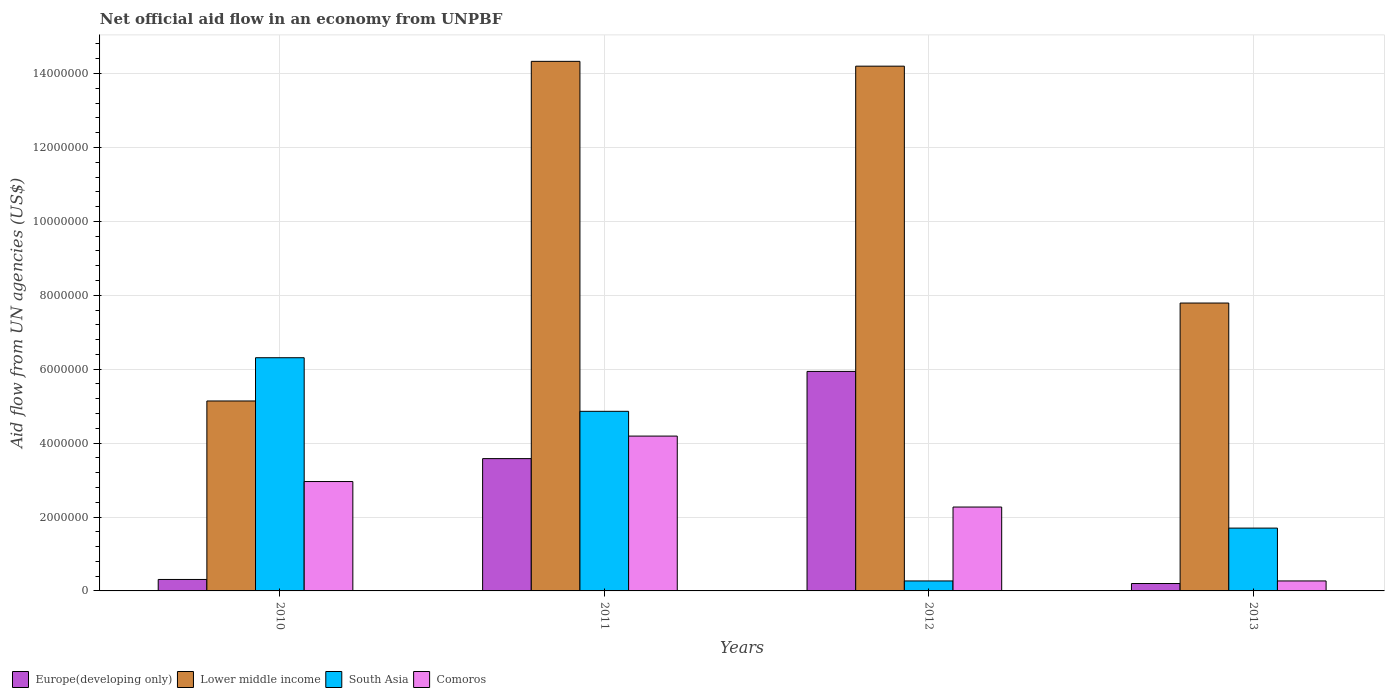How many groups of bars are there?
Offer a terse response. 4. Are the number of bars per tick equal to the number of legend labels?
Your response must be concise. Yes. How many bars are there on the 1st tick from the left?
Provide a short and direct response. 4. What is the label of the 1st group of bars from the left?
Provide a succinct answer. 2010. What is the net official aid flow in Comoros in 2013?
Your answer should be compact. 2.70e+05. Across all years, what is the maximum net official aid flow in South Asia?
Your response must be concise. 6.31e+06. Across all years, what is the minimum net official aid flow in Europe(developing only)?
Make the answer very short. 2.00e+05. What is the total net official aid flow in Europe(developing only) in the graph?
Offer a very short reply. 1.00e+07. What is the difference between the net official aid flow in South Asia in 2011 and that in 2012?
Your response must be concise. 4.59e+06. What is the difference between the net official aid flow in South Asia in 2010 and the net official aid flow in Europe(developing only) in 2012?
Your response must be concise. 3.70e+05. What is the average net official aid flow in Lower middle income per year?
Your response must be concise. 1.04e+07. In the year 2013, what is the difference between the net official aid flow in South Asia and net official aid flow in Comoros?
Offer a terse response. 1.43e+06. What is the ratio of the net official aid flow in Lower middle income in 2011 to that in 2012?
Ensure brevity in your answer.  1.01. What is the difference between the highest and the second highest net official aid flow in South Asia?
Offer a terse response. 1.45e+06. What is the difference between the highest and the lowest net official aid flow in Europe(developing only)?
Your response must be concise. 5.74e+06. Is it the case that in every year, the sum of the net official aid flow in Comoros and net official aid flow in South Asia is greater than the sum of net official aid flow in Europe(developing only) and net official aid flow in Lower middle income?
Your response must be concise. No. What does the 3rd bar from the left in 2013 represents?
Give a very brief answer. South Asia. What does the 1st bar from the right in 2012 represents?
Provide a succinct answer. Comoros. How many years are there in the graph?
Your answer should be compact. 4. What is the difference between two consecutive major ticks on the Y-axis?
Provide a succinct answer. 2.00e+06. Are the values on the major ticks of Y-axis written in scientific E-notation?
Your answer should be compact. No. Does the graph contain any zero values?
Your response must be concise. No. Does the graph contain grids?
Offer a very short reply. Yes. Where does the legend appear in the graph?
Your answer should be very brief. Bottom left. How many legend labels are there?
Offer a terse response. 4. How are the legend labels stacked?
Provide a succinct answer. Horizontal. What is the title of the graph?
Your answer should be very brief. Net official aid flow in an economy from UNPBF. Does "El Salvador" appear as one of the legend labels in the graph?
Give a very brief answer. No. What is the label or title of the X-axis?
Keep it short and to the point. Years. What is the label or title of the Y-axis?
Offer a terse response. Aid flow from UN agencies (US$). What is the Aid flow from UN agencies (US$) in Europe(developing only) in 2010?
Offer a terse response. 3.10e+05. What is the Aid flow from UN agencies (US$) in Lower middle income in 2010?
Ensure brevity in your answer.  5.14e+06. What is the Aid flow from UN agencies (US$) in South Asia in 2010?
Your answer should be very brief. 6.31e+06. What is the Aid flow from UN agencies (US$) of Comoros in 2010?
Ensure brevity in your answer.  2.96e+06. What is the Aid flow from UN agencies (US$) of Europe(developing only) in 2011?
Your answer should be compact. 3.58e+06. What is the Aid flow from UN agencies (US$) of Lower middle income in 2011?
Your response must be concise. 1.43e+07. What is the Aid flow from UN agencies (US$) in South Asia in 2011?
Your answer should be compact. 4.86e+06. What is the Aid flow from UN agencies (US$) in Comoros in 2011?
Provide a short and direct response. 4.19e+06. What is the Aid flow from UN agencies (US$) of Europe(developing only) in 2012?
Provide a succinct answer. 5.94e+06. What is the Aid flow from UN agencies (US$) of Lower middle income in 2012?
Ensure brevity in your answer.  1.42e+07. What is the Aid flow from UN agencies (US$) of Comoros in 2012?
Your answer should be compact. 2.27e+06. What is the Aid flow from UN agencies (US$) of Europe(developing only) in 2013?
Provide a short and direct response. 2.00e+05. What is the Aid flow from UN agencies (US$) of Lower middle income in 2013?
Provide a short and direct response. 7.79e+06. What is the Aid flow from UN agencies (US$) in South Asia in 2013?
Your answer should be very brief. 1.70e+06. Across all years, what is the maximum Aid flow from UN agencies (US$) of Europe(developing only)?
Provide a short and direct response. 5.94e+06. Across all years, what is the maximum Aid flow from UN agencies (US$) of Lower middle income?
Provide a succinct answer. 1.43e+07. Across all years, what is the maximum Aid flow from UN agencies (US$) in South Asia?
Keep it short and to the point. 6.31e+06. Across all years, what is the maximum Aid flow from UN agencies (US$) of Comoros?
Make the answer very short. 4.19e+06. Across all years, what is the minimum Aid flow from UN agencies (US$) of Europe(developing only)?
Provide a short and direct response. 2.00e+05. Across all years, what is the minimum Aid flow from UN agencies (US$) in Lower middle income?
Provide a succinct answer. 5.14e+06. Across all years, what is the minimum Aid flow from UN agencies (US$) in South Asia?
Your response must be concise. 2.70e+05. What is the total Aid flow from UN agencies (US$) of Europe(developing only) in the graph?
Your response must be concise. 1.00e+07. What is the total Aid flow from UN agencies (US$) of Lower middle income in the graph?
Give a very brief answer. 4.15e+07. What is the total Aid flow from UN agencies (US$) of South Asia in the graph?
Your response must be concise. 1.31e+07. What is the total Aid flow from UN agencies (US$) in Comoros in the graph?
Keep it short and to the point. 9.69e+06. What is the difference between the Aid flow from UN agencies (US$) in Europe(developing only) in 2010 and that in 2011?
Provide a short and direct response. -3.27e+06. What is the difference between the Aid flow from UN agencies (US$) in Lower middle income in 2010 and that in 2011?
Offer a terse response. -9.19e+06. What is the difference between the Aid flow from UN agencies (US$) of South Asia in 2010 and that in 2011?
Offer a very short reply. 1.45e+06. What is the difference between the Aid flow from UN agencies (US$) in Comoros in 2010 and that in 2011?
Provide a short and direct response. -1.23e+06. What is the difference between the Aid flow from UN agencies (US$) of Europe(developing only) in 2010 and that in 2012?
Offer a terse response. -5.63e+06. What is the difference between the Aid flow from UN agencies (US$) in Lower middle income in 2010 and that in 2012?
Your answer should be compact. -9.06e+06. What is the difference between the Aid flow from UN agencies (US$) in South Asia in 2010 and that in 2012?
Make the answer very short. 6.04e+06. What is the difference between the Aid flow from UN agencies (US$) of Comoros in 2010 and that in 2012?
Ensure brevity in your answer.  6.90e+05. What is the difference between the Aid flow from UN agencies (US$) in Lower middle income in 2010 and that in 2013?
Your answer should be very brief. -2.65e+06. What is the difference between the Aid flow from UN agencies (US$) in South Asia in 2010 and that in 2013?
Your answer should be compact. 4.61e+06. What is the difference between the Aid flow from UN agencies (US$) in Comoros in 2010 and that in 2013?
Offer a very short reply. 2.69e+06. What is the difference between the Aid flow from UN agencies (US$) of Europe(developing only) in 2011 and that in 2012?
Your response must be concise. -2.36e+06. What is the difference between the Aid flow from UN agencies (US$) of South Asia in 2011 and that in 2012?
Offer a terse response. 4.59e+06. What is the difference between the Aid flow from UN agencies (US$) of Comoros in 2011 and that in 2012?
Your response must be concise. 1.92e+06. What is the difference between the Aid flow from UN agencies (US$) of Europe(developing only) in 2011 and that in 2013?
Provide a succinct answer. 3.38e+06. What is the difference between the Aid flow from UN agencies (US$) of Lower middle income in 2011 and that in 2013?
Offer a very short reply. 6.54e+06. What is the difference between the Aid flow from UN agencies (US$) in South Asia in 2011 and that in 2013?
Offer a terse response. 3.16e+06. What is the difference between the Aid flow from UN agencies (US$) of Comoros in 2011 and that in 2013?
Your answer should be compact. 3.92e+06. What is the difference between the Aid flow from UN agencies (US$) in Europe(developing only) in 2012 and that in 2013?
Your answer should be compact. 5.74e+06. What is the difference between the Aid flow from UN agencies (US$) in Lower middle income in 2012 and that in 2013?
Keep it short and to the point. 6.41e+06. What is the difference between the Aid flow from UN agencies (US$) in South Asia in 2012 and that in 2013?
Provide a succinct answer. -1.43e+06. What is the difference between the Aid flow from UN agencies (US$) in Europe(developing only) in 2010 and the Aid flow from UN agencies (US$) in Lower middle income in 2011?
Offer a very short reply. -1.40e+07. What is the difference between the Aid flow from UN agencies (US$) of Europe(developing only) in 2010 and the Aid flow from UN agencies (US$) of South Asia in 2011?
Give a very brief answer. -4.55e+06. What is the difference between the Aid flow from UN agencies (US$) in Europe(developing only) in 2010 and the Aid flow from UN agencies (US$) in Comoros in 2011?
Ensure brevity in your answer.  -3.88e+06. What is the difference between the Aid flow from UN agencies (US$) of Lower middle income in 2010 and the Aid flow from UN agencies (US$) of Comoros in 2011?
Make the answer very short. 9.50e+05. What is the difference between the Aid flow from UN agencies (US$) of South Asia in 2010 and the Aid flow from UN agencies (US$) of Comoros in 2011?
Offer a very short reply. 2.12e+06. What is the difference between the Aid flow from UN agencies (US$) of Europe(developing only) in 2010 and the Aid flow from UN agencies (US$) of Lower middle income in 2012?
Offer a terse response. -1.39e+07. What is the difference between the Aid flow from UN agencies (US$) of Europe(developing only) in 2010 and the Aid flow from UN agencies (US$) of South Asia in 2012?
Offer a very short reply. 4.00e+04. What is the difference between the Aid flow from UN agencies (US$) of Europe(developing only) in 2010 and the Aid flow from UN agencies (US$) of Comoros in 2012?
Your response must be concise. -1.96e+06. What is the difference between the Aid flow from UN agencies (US$) in Lower middle income in 2010 and the Aid flow from UN agencies (US$) in South Asia in 2012?
Your response must be concise. 4.87e+06. What is the difference between the Aid flow from UN agencies (US$) of Lower middle income in 2010 and the Aid flow from UN agencies (US$) of Comoros in 2012?
Provide a short and direct response. 2.87e+06. What is the difference between the Aid flow from UN agencies (US$) of South Asia in 2010 and the Aid flow from UN agencies (US$) of Comoros in 2012?
Give a very brief answer. 4.04e+06. What is the difference between the Aid flow from UN agencies (US$) of Europe(developing only) in 2010 and the Aid flow from UN agencies (US$) of Lower middle income in 2013?
Give a very brief answer. -7.48e+06. What is the difference between the Aid flow from UN agencies (US$) in Europe(developing only) in 2010 and the Aid flow from UN agencies (US$) in South Asia in 2013?
Offer a terse response. -1.39e+06. What is the difference between the Aid flow from UN agencies (US$) of Europe(developing only) in 2010 and the Aid flow from UN agencies (US$) of Comoros in 2013?
Offer a very short reply. 4.00e+04. What is the difference between the Aid flow from UN agencies (US$) of Lower middle income in 2010 and the Aid flow from UN agencies (US$) of South Asia in 2013?
Your answer should be compact. 3.44e+06. What is the difference between the Aid flow from UN agencies (US$) in Lower middle income in 2010 and the Aid flow from UN agencies (US$) in Comoros in 2013?
Provide a succinct answer. 4.87e+06. What is the difference between the Aid flow from UN agencies (US$) in South Asia in 2010 and the Aid flow from UN agencies (US$) in Comoros in 2013?
Ensure brevity in your answer.  6.04e+06. What is the difference between the Aid flow from UN agencies (US$) in Europe(developing only) in 2011 and the Aid flow from UN agencies (US$) in Lower middle income in 2012?
Ensure brevity in your answer.  -1.06e+07. What is the difference between the Aid flow from UN agencies (US$) of Europe(developing only) in 2011 and the Aid flow from UN agencies (US$) of South Asia in 2012?
Your answer should be very brief. 3.31e+06. What is the difference between the Aid flow from UN agencies (US$) of Europe(developing only) in 2011 and the Aid flow from UN agencies (US$) of Comoros in 2012?
Provide a short and direct response. 1.31e+06. What is the difference between the Aid flow from UN agencies (US$) of Lower middle income in 2011 and the Aid flow from UN agencies (US$) of South Asia in 2012?
Your response must be concise. 1.41e+07. What is the difference between the Aid flow from UN agencies (US$) in Lower middle income in 2011 and the Aid flow from UN agencies (US$) in Comoros in 2012?
Your response must be concise. 1.21e+07. What is the difference between the Aid flow from UN agencies (US$) in South Asia in 2011 and the Aid flow from UN agencies (US$) in Comoros in 2012?
Give a very brief answer. 2.59e+06. What is the difference between the Aid flow from UN agencies (US$) of Europe(developing only) in 2011 and the Aid flow from UN agencies (US$) of Lower middle income in 2013?
Make the answer very short. -4.21e+06. What is the difference between the Aid flow from UN agencies (US$) in Europe(developing only) in 2011 and the Aid flow from UN agencies (US$) in South Asia in 2013?
Your answer should be very brief. 1.88e+06. What is the difference between the Aid flow from UN agencies (US$) of Europe(developing only) in 2011 and the Aid flow from UN agencies (US$) of Comoros in 2013?
Give a very brief answer. 3.31e+06. What is the difference between the Aid flow from UN agencies (US$) in Lower middle income in 2011 and the Aid flow from UN agencies (US$) in South Asia in 2013?
Provide a short and direct response. 1.26e+07. What is the difference between the Aid flow from UN agencies (US$) of Lower middle income in 2011 and the Aid flow from UN agencies (US$) of Comoros in 2013?
Give a very brief answer. 1.41e+07. What is the difference between the Aid flow from UN agencies (US$) of South Asia in 2011 and the Aid flow from UN agencies (US$) of Comoros in 2013?
Your answer should be compact. 4.59e+06. What is the difference between the Aid flow from UN agencies (US$) in Europe(developing only) in 2012 and the Aid flow from UN agencies (US$) in Lower middle income in 2013?
Provide a succinct answer. -1.85e+06. What is the difference between the Aid flow from UN agencies (US$) in Europe(developing only) in 2012 and the Aid flow from UN agencies (US$) in South Asia in 2013?
Give a very brief answer. 4.24e+06. What is the difference between the Aid flow from UN agencies (US$) in Europe(developing only) in 2012 and the Aid flow from UN agencies (US$) in Comoros in 2013?
Keep it short and to the point. 5.67e+06. What is the difference between the Aid flow from UN agencies (US$) in Lower middle income in 2012 and the Aid flow from UN agencies (US$) in South Asia in 2013?
Ensure brevity in your answer.  1.25e+07. What is the difference between the Aid flow from UN agencies (US$) in Lower middle income in 2012 and the Aid flow from UN agencies (US$) in Comoros in 2013?
Keep it short and to the point. 1.39e+07. What is the difference between the Aid flow from UN agencies (US$) in South Asia in 2012 and the Aid flow from UN agencies (US$) in Comoros in 2013?
Make the answer very short. 0. What is the average Aid flow from UN agencies (US$) of Europe(developing only) per year?
Make the answer very short. 2.51e+06. What is the average Aid flow from UN agencies (US$) of Lower middle income per year?
Your response must be concise. 1.04e+07. What is the average Aid flow from UN agencies (US$) of South Asia per year?
Provide a short and direct response. 3.28e+06. What is the average Aid flow from UN agencies (US$) of Comoros per year?
Offer a terse response. 2.42e+06. In the year 2010, what is the difference between the Aid flow from UN agencies (US$) of Europe(developing only) and Aid flow from UN agencies (US$) of Lower middle income?
Your response must be concise. -4.83e+06. In the year 2010, what is the difference between the Aid flow from UN agencies (US$) in Europe(developing only) and Aid flow from UN agencies (US$) in South Asia?
Ensure brevity in your answer.  -6.00e+06. In the year 2010, what is the difference between the Aid flow from UN agencies (US$) in Europe(developing only) and Aid flow from UN agencies (US$) in Comoros?
Offer a terse response. -2.65e+06. In the year 2010, what is the difference between the Aid flow from UN agencies (US$) in Lower middle income and Aid flow from UN agencies (US$) in South Asia?
Provide a succinct answer. -1.17e+06. In the year 2010, what is the difference between the Aid flow from UN agencies (US$) of Lower middle income and Aid flow from UN agencies (US$) of Comoros?
Your answer should be very brief. 2.18e+06. In the year 2010, what is the difference between the Aid flow from UN agencies (US$) in South Asia and Aid flow from UN agencies (US$) in Comoros?
Provide a succinct answer. 3.35e+06. In the year 2011, what is the difference between the Aid flow from UN agencies (US$) of Europe(developing only) and Aid flow from UN agencies (US$) of Lower middle income?
Your answer should be compact. -1.08e+07. In the year 2011, what is the difference between the Aid flow from UN agencies (US$) in Europe(developing only) and Aid flow from UN agencies (US$) in South Asia?
Offer a terse response. -1.28e+06. In the year 2011, what is the difference between the Aid flow from UN agencies (US$) of Europe(developing only) and Aid flow from UN agencies (US$) of Comoros?
Ensure brevity in your answer.  -6.10e+05. In the year 2011, what is the difference between the Aid flow from UN agencies (US$) in Lower middle income and Aid flow from UN agencies (US$) in South Asia?
Make the answer very short. 9.47e+06. In the year 2011, what is the difference between the Aid flow from UN agencies (US$) in Lower middle income and Aid flow from UN agencies (US$) in Comoros?
Provide a short and direct response. 1.01e+07. In the year 2011, what is the difference between the Aid flow from UN agencies (US$) of South Asia and Aid flow from UN agencies (US$) of Comoros?
Ensure brevity in your answer.  6.70e+05. In the year 2012, what is the difference between the Aid flow from UN agencies (US$) in Europe(developing only) and Aid flow from UN agencies (US$) in Lower middle income?
Give a very brief answer. -8.26e+06. In the year 2012, what is the difference between the Aid flow from UN agencies (US$) in Europe(developing only) and Aid flow from UN agencies (US$) in South Asia?
Provide a short and direct response. 5.67e+06. In the year 2012, what is the difference between the Aid flow from UN agencies (US$) in Europe(developing only) and Aid flow from UN agencies (US$) in Comoros?
Provide a succinct answer. 3.67e+06. In the year 2012, what is the difference between the Aid flow from UN agencies (US$) in Lower middle income and Aid flow from UN agencies (US$) in South Asia?
Provide a short and direct response. 1.39e+07. In the year 2012, what is the difference between the Aid flow from UN agencies (US$) in Lower middle income and Aid flow from UN agencies (US$) in Comoros?
Provide a succinct answer. 1.19e+07. In the year 2013, what is the difference between the Aid flow from UN agencies (US$) in Europe(developing only) and Aid flow from UN agencies (US$) in Lower middle income?
Provide a short and direct response. -7.59e+06. In the year 2013, what is the difference between the Aid flow from UN agencies (US$) in Europe(developing only) and Aid flow from UN agencies (US$) in South Asia?
Ensure brevity in your answer.  -1.50e+06. In the year 2013, what is the difference between the Aid flow from UN agencies (US$) in Europe(developing only) and Aid flow from UN agencies (US$) in Comoros?
Offer a terse response. -7.00e+04. In the year 2013, what is the difference between the Aid flow from UN agencies (US$) of Lower middle income and Aid flow from UN agencies (US$) of South Asia?
Offer a very short reply. 6.09e+06. In the year 2013, what is the difference between the Aid flow from UN agencies (US$) in Lower middle income and Aid flow from UN agencies (US$) in Comoros?
Provide a short and direct response. 7.52e+06. In the year 2013, what is the difference between the Aid flow from UN agencies (US$) of South Asia and Aid flow from UN agencies (US$) of Comoros?
Provide a short and direct response. 1.43e+06. What is the ratio of the Aid flow from UN agencies (US$) of Europe(developing only) in 2010 to that in 2011?
Provide a succinct answer. 0.09. What is the ratio of the Aid flow from UN agencies (US$) of Lower middle income in 2010 to that in 2011?
Offer a terse response. 0.36. What is the ratio of the Aid flow from UN agencies (US$) of South Asia in 2010 to that in 2011?
Give a very brief answer. 1.3. What is the ratio of the Aid flow from UN agencies (US$) of Comoros in 2010 to that in 2011?
Provide a short and direct response. 0.71. What is the ratio of the Aid flow from UN agencies (US$) of Europe(developing only) in 2010 to that in 2012?
Ensure brevity in your answer.  0.05. What is the ratio of the Aid flow from UN agencies (US$) in Lower middle income in 2010 to that in 2012?
Provide a succinct answer. 0.36. What is the ratio of the Aid flow from UN agencies (US$) of South Asia in 2010 to that in 2012?
Make the answer very short. 23.37. What is the ratio of the Aid flow from UN agencies (US$) of Comoros in 2010 to that in 2012?
Ensure brevity in your answer.  1.3. What is the ratio of the Aid flow from UN agencies (US$) in Europe(developing only) in 2010 to that in 2013?
Provide a succinct answer. 1.55. What is the ratio of the Aid flow from UN agencies (US$) of Lower middle income in 2010 to that in 2013?
Ensure brevity in your answer.  0.66. What is the ratio of the Aid flow from UN agencies (US$) of South Asia in 2010 to that in 2013?
Provide a succinct answer. 3.71. What is the ratio of the Aid flow from UN agencies (US$) of Comoros in 2010 to that in 2013?
Provide a short and direct response. 10.96. What is the ratio of the Aid flow from UN agencies (US$) in Europe(developing only) in 2011 to that in 2012?
Provide a succinct answer. 0.6. What is the ratio of the Aid flow from UN agencies (US$) of Lower middle income in 2011 to that in 2012?
Offer a very short reply. 1.01. What is the ratio of the Aid flow from UN agencies (US$) of Comoros in 2011 to that in 2012?
Your answer should be compact. 1.85. What is the ratio of the Aid flow from UN agencies (US$) of Europe(developing only) in 2011 to that in 2013?
Give a very brief answer. 17.9. What is the ratio of the Aid flow from UN agencies (US$) in Lower middle income in 2011 to that in 2013?
Your answer should be compact. 1.84. What is the ratio of the Aid flow from UN agencies (US$) in South Asia in 2011 to that in 2013?
Offer a very short reply. 2.86. What is the ratio of the Aid flow from UN agencies (US$) of Comoros in 2011 to that in 2013?
Give a very brief answer. 15.52. What is the ratio of the Aid flow from UN agencies (US$) in Europe(developing only) in 2012 to that in 2013?
Provide a short and direct response. 29.7. What is the ratio of the Aid flow from UN agencies (US$) in Lower middle income in 2012 to that in 2013?
Ensure brevity in your answer.  1.82. What is the ratio of the Aid flow from UN agencies (US$) of South Asia in 2012 to that in 2013?
Your answer should be compact. 0.16. What is the ratio of the Aid flow from UN agencies (US$) of Comoros in 2012 to that in 2013?
Make the answer very short. 8.41. What is the difference between the highest and the second highest Aid flow from UN agencies (US$) of Europe(developing only)?
Offer a very short reply. 2.36e+06. What is the difference between the highest and the second highest Aid flow from UN agencies (US$) in South Asia?
Your response must be concise. 1.45e+06. What is the difference between the highest and the second highest Aid flow from UN agencies (US$) of Comoros?
Offer a very short reply. 1.23e+06. What is the difference between the highest and the lowest Aid flow from UN agencies (US$) of Europe(developing only)?
Your response must be concise. 5.74e+06. What is the difference between the highest and the lowest Aid flow from UN agencies (US$) of Lower middle income?
Ensure brevity in your answer.  9.19e+06. What is the difference between the highest and the lowest Aid flow from UN agencies (US$) in South Asia?
Provide a succinct answer. 6.04e+06. What is the difference between the highest and the lowest Aid flow from UN agencies (US$) in Comoros?
Provide a succinct answer. 3.92e+06. 